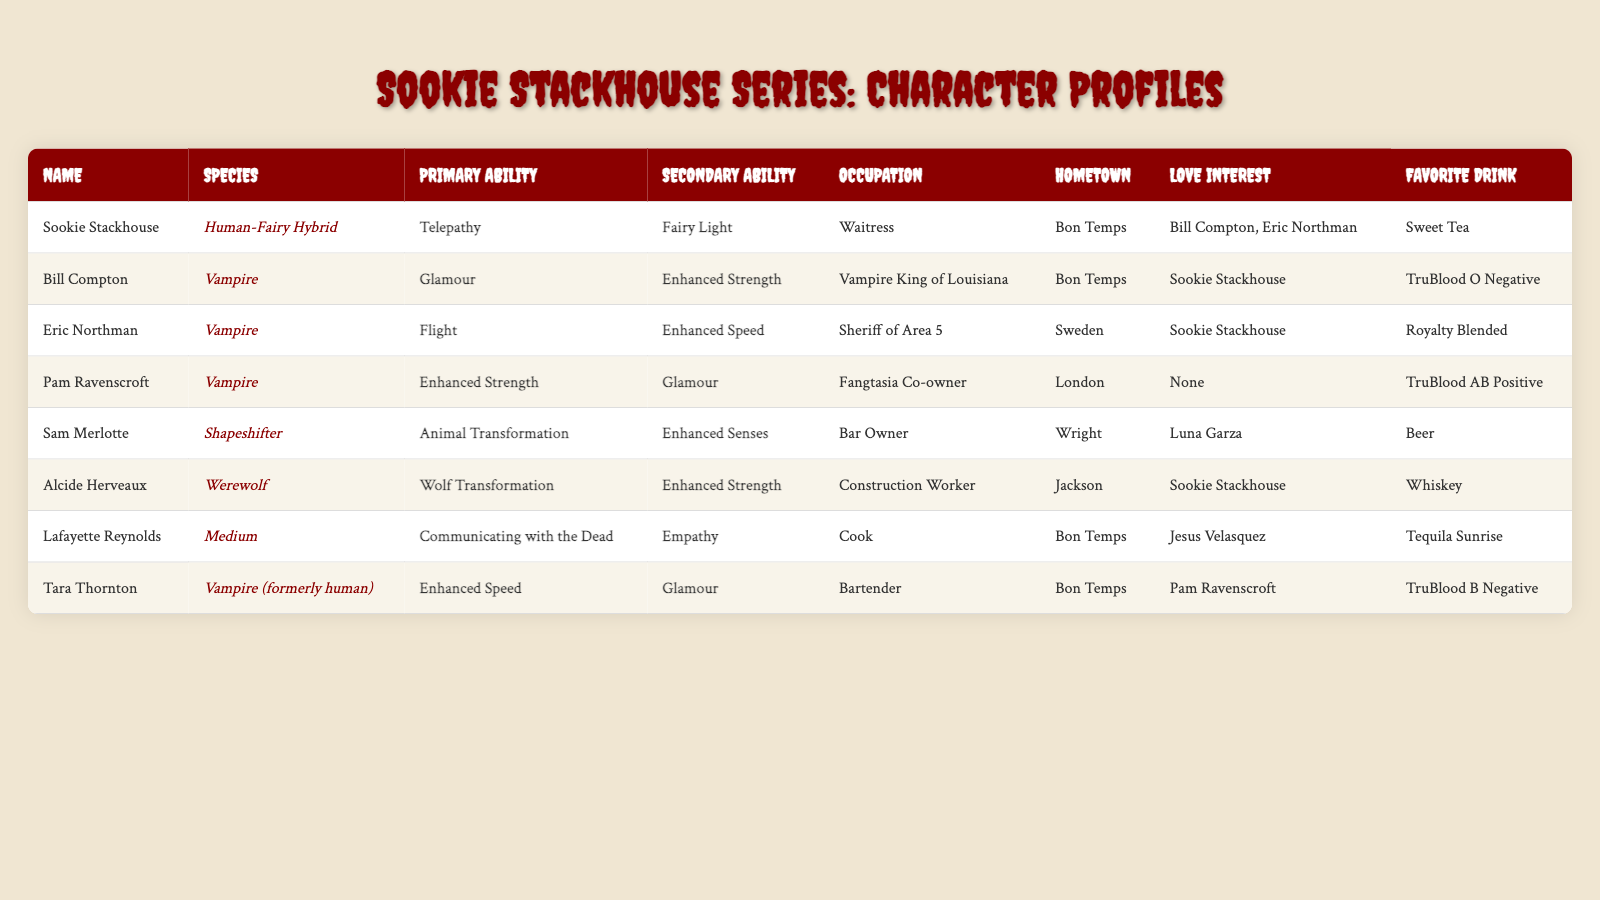What is Sookie Stackhouse's primary ability? Sookie Stackhouse's primary ability, as listed in the table, is telepathy.
Answer: Telepathy Which character has the occupation of Vampire King of Louisiana? The character with the occupation of Vampire King of Louisiana is Bill Compton, as stated in the occupation column.
Answer: Bill Compton How many characters have Enhanced Strength as a secondary ability? From the table, Bill Compton, Alcide Herveaux, and Pam Ravenscroft all have Enhanced Strength as a secondary ability. Therefore, there are three characters.
Answer: 3 Is there a character who is both a Vampire and has Enhanced Speed? The table provides information about Tara Thornton, who is a Vampire and has Enhanced Speed as a primary ability. Therefore, the answer is yes.
Answer: Yes Which character's favorite drink is Whiskey? In the table, Alcide Herveaux's favorite drink is listed as Whiskey.
Answer: Alcide Herveaux List the love interests of Sookie Stackhouse. The table indicates that Sookie Stackhouse's love interests are Bill Compton and Eric Northman.
Answer: Bill Compton and Eric Northman Who is the only character without a specified love interest? According to the table, Pam Ravenscroft is the only character who does not have a specified love interest.
Answer: Pam Ravenscroft Which species does Sam Merlotte belong to? The table states that Sam Merlotte is a shapeshifter.
Answer: Shapeshifter Count the total number of characters from Bon Temps. By reviewing the table, Sookie Stackhouse, Bill Compton, Lafayette Reynolds, and Tara Thornton are all listed as being from Bon Temps, totaling four characters.
Answer: 4 Which character has the secondary ability of communicating with the dead? The table shows that Lafayette Reynolds possesses the secondary ability of communicating with the dead.
Answer: Lafayette Reynolds If we consider the characters in Bon Temps, how many have drinking preferences listed as TruBlood? From the table, Bill Compton has TruBlood O Negative and Tara Thornton has TruBlood B Negative; thus, there are two characters with TruBlood preferences.
Answer: 2 